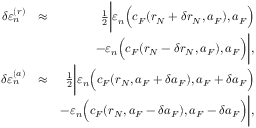<formula> <loc_0><loc_0><loc_500><loc_500>\begin{array} { r l r } { \delta \varepsilon _ { n } ^ { ( r ) } } & { \approx } & { \frac { 1 } { 2 } \left | \varepsilon _ { n } \left ( c _ { F } ( r _ { N } + \delta r _ { N } , a _ { F } ) , a _ { F } \right ) } \\ & { - \varepsilon _ { n } \left ( c _ { F } ( r _ { N } - \delta r _ { N } , a _ { F } ) , a _ { F } \right ) \right | , } \\ { \delta \varepsilon _ { n } ^ { ( a ) } } & { \approx } & { \frac { 1 } { 2 } \left | \varepsilon _ { n } \left ( c _ { F } ( r _ { N } , a _ { F } + \delta a _ { F } ) , a _ { F } + \delta a _ { F } \right ) } \\ & { - \varepsilon _ { n } \left ( c _ { F } ( r _ { N } , a _ { F } - \delta a _ { F } ) , a _ { F } - \delta a _ { F } \right ) \right | , } \end{array}</formula> 